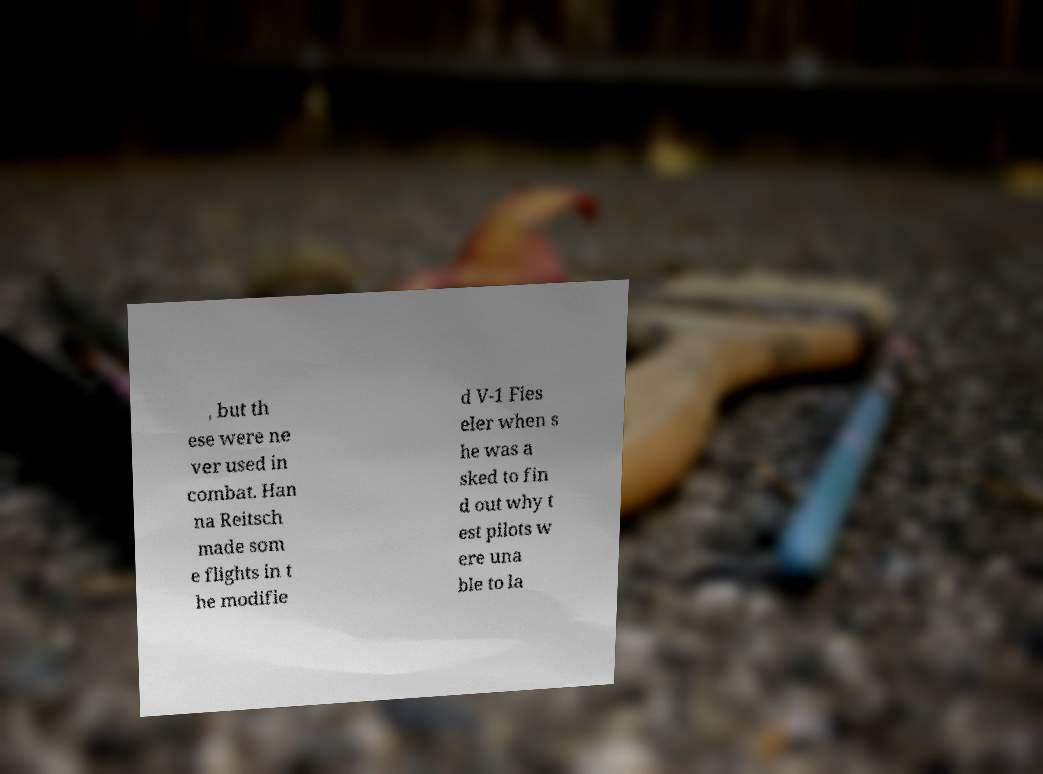There's text embedded in this image that I need extracted. Can you transcribe it verbatim? , but th ese were ne ver used in combat. Han na Reitsch made som e flights in t he modifie d V-1 Fies eler when s he was a sked to fin d out why t est pilots w ere una ble to la 